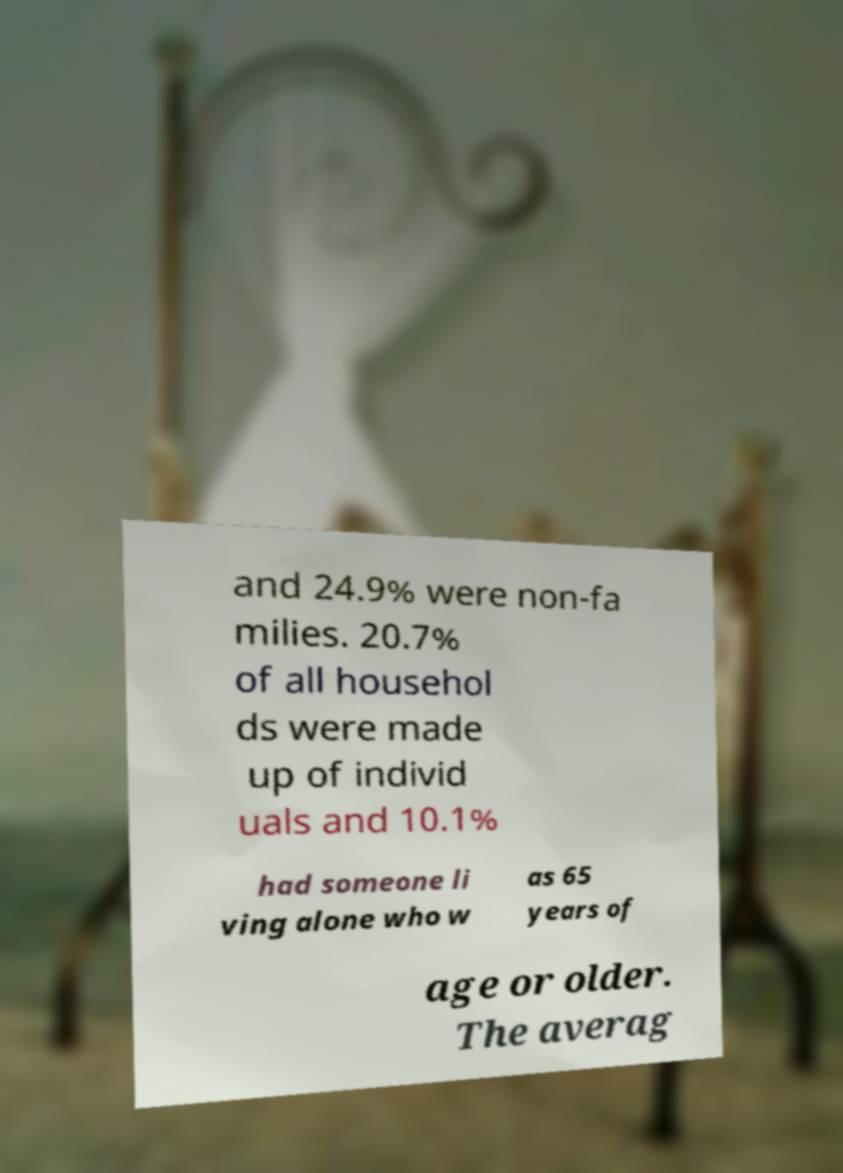Can you accurately transcribe the text from the provided image for me? and 24.9% were non-fa milies. 20.7% of all househol ds were made up of individ uals and 10.1% had someone li ving alone who w as 65 years of age or older. The averag 